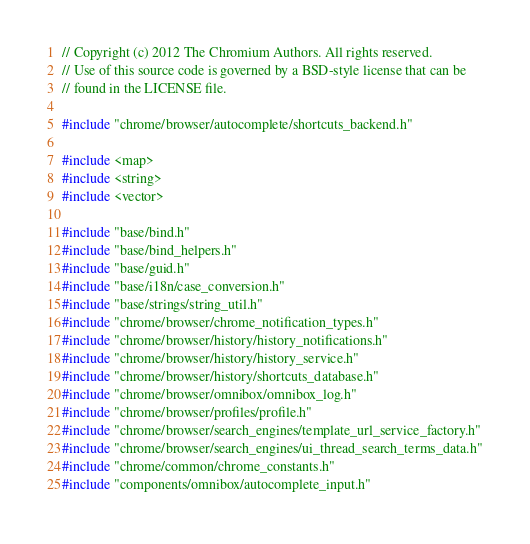Convert code to text. <code><loc_0><loc_0><loc_500><loc_500><_C++_>// Copyright (c) 2012 The Chromium Authors. All rights reserved.
// Use of this source code is governed by a BSD-style license that can be
// found in the LICENSE file.

#include "chrome/browser/autocomplete/shortcuts_backend.h"

#include <map>
#include <string>
#include <vector>

#include "base/bind.h"
#include "base/bind_helpers.h"
#include "base/guid.h"
#include "base/i18n/case_conversion.h"
#include "base/strings/string_util.h"
#include "chrome/browser/chrome_notification_types.h"
#include "chrome/browser/history/history_notifications.h"
#include "chrome/browser/history/history_service.h"
#include "chrome/browser/history/shortcuts_database.h"
#include "chrome/browser/omnibox/omnibox_log.h"
#include "chrome/browser/profiles/profile.h"
#include "chrome/browser/search_engines/template_url_service_factory.h"
#include "chrome/browser/search_engines/ui_thread_search_terms_data.h"
#include "chrome/common/chrome_constants.h"
#include "components/omnibox/autocomplete_input.h"</code> 